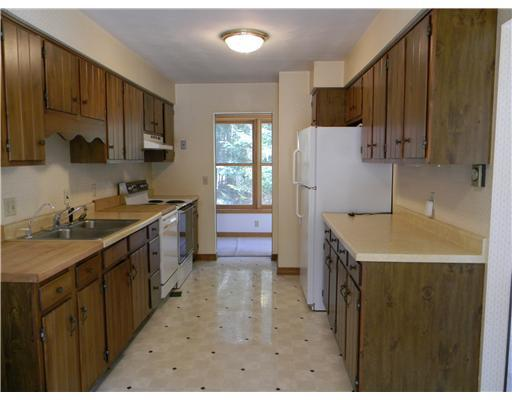How many cooks prepared meals in this kitchen today? Please explain your reasoning. none. The kitchen is clean. it is devoid of garbage and dirty pots and pans. 